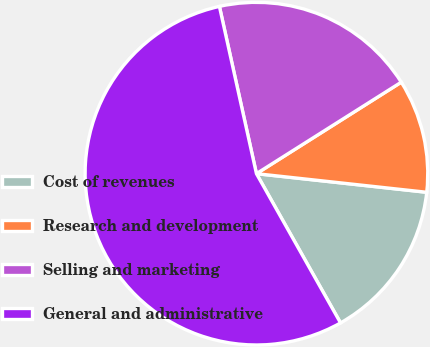Convert chart to OTSL. <chart><loc_0><loc_0><loc_500><loc_500><pie_chart><fcel>Cost of revenues<fcel>Research and development<fcel>Selling and marketing<fcel>General and administrative<nl><fcel>15.1%<fcel>10.7%<fcel>19.5%<fcel>54.7%<nl></chart> 